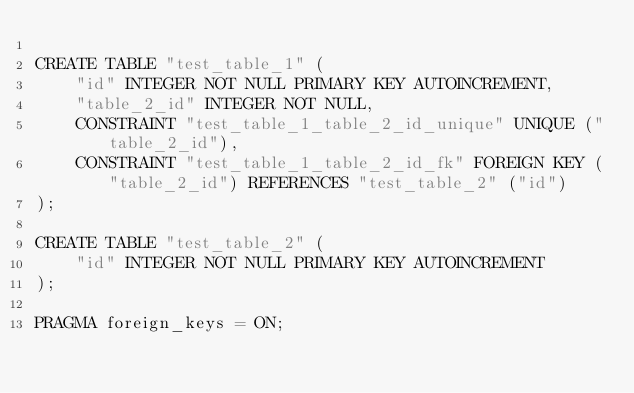Convert code to text. <code><loc_0><loc_0><loc_500><loc_500><_SQL_>
CREATE TABLE "test_table_1" (
    "id" INTEGER NOT NULL PRIMARY KEY AUTOINCREMENT,
    "table_2_id" INTEGER NOT NULL,
    CONSTRAINT "test_table_1_table_2_id_unique" UNIQUE ("table_2_id"),
    CONSTRAINT "test_table_1_table_2_id_fk" FOREIGN KEY ("table_2_id") REFERENCES "test_table_2" ("id")
);

CREATE TABLE "test_table_2" (
    "id" INTEGER NOT NULL PRIMARY KEY AUTOINCREMENT
);

PRAGMA foreign_keys = ON;</code> 